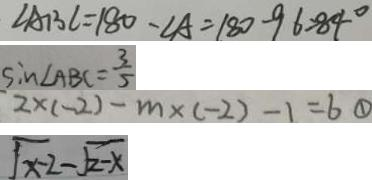<formula> <loc_0><loc_0><loc_500><loc_500>\angle A B C = 1 8 0 - \angle A = 1 8 0 - 9 6 = 8 4 ^ { \circ } 
 \sin \angle A B C = \frac { 3 } { 5 } 
 2 \times ( - 2 ) - m \times ( - 2 ) - 1 = 6 \textcircled { 1 } 
 \sqrt { x - 2 } - \sqrt { 2 - x }</formula> 